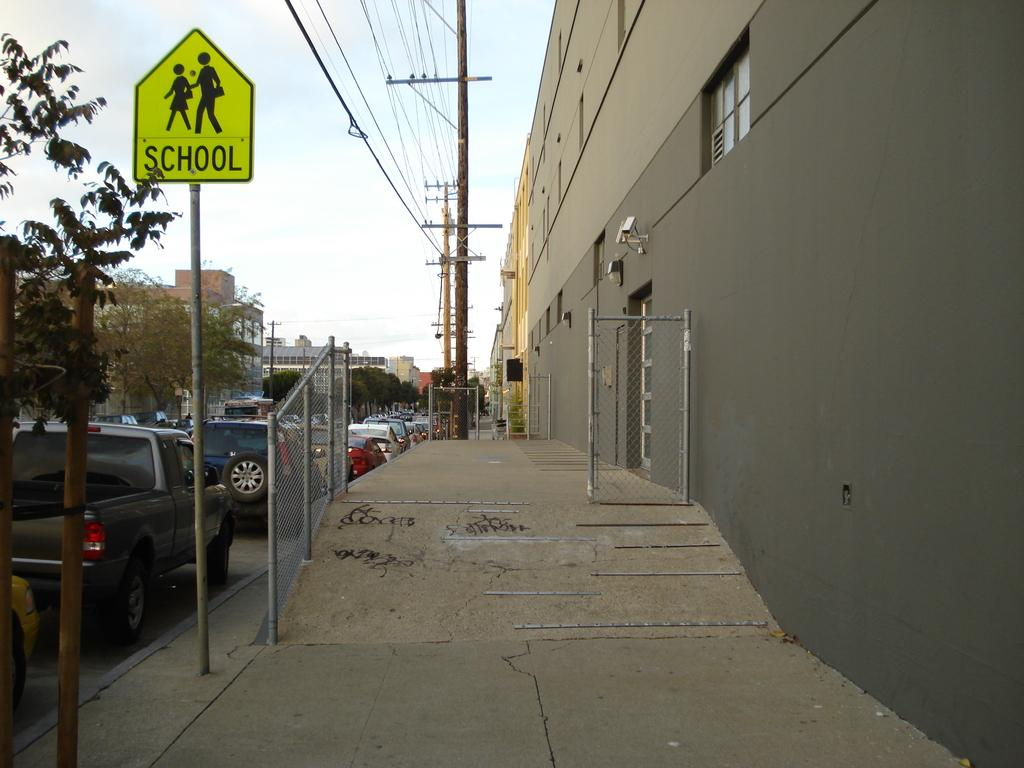<image>
Summarize the visual content of the image. A grey building with a School crossing sign next to it 